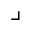<formula> <loc_0><loc_0><loc_500><loc_500>\lrcorner</formula> 